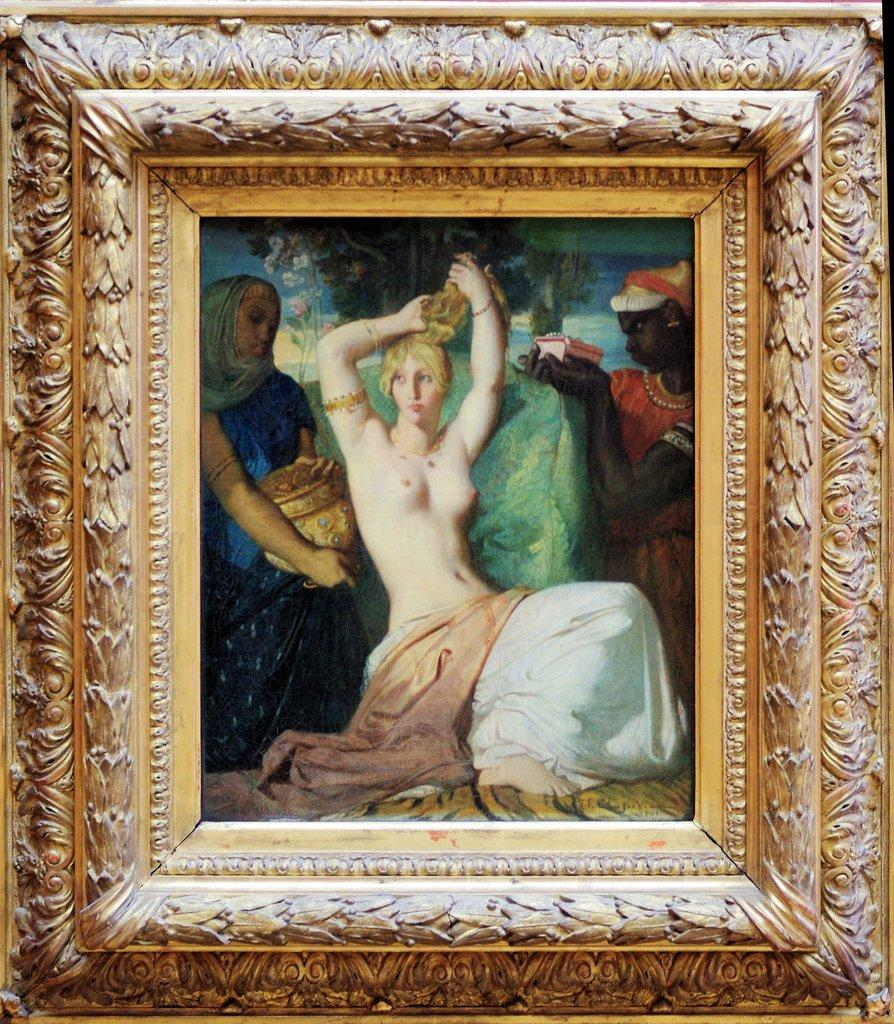What object in the image contains a visual representation? There is a photo frame in the image, and it contains a painting. What is the subject matter of the visual representation in the photo frame? The painting depicts people. How many trucks are visible in the painting inside the photo frame? There are no trucks visible in the painting inside the photo frame; the painting depicts people. Is there a notebook present in the image? There is no mention of a notebook in the provided facts about the image. 